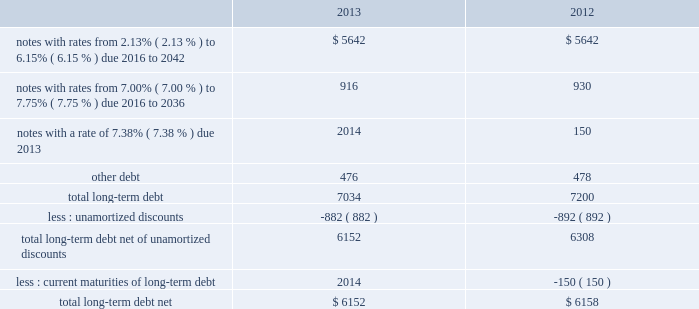As of december 31 , 2013 and 2012 , our liabilities associated with unrecognized tax benefits are not material .
We and our subsidiaries file income tax returns in the u.s .
Federal jurisdiction and various foreign jurisdictions .
With few exceptions , the statute of limitations is no longer open for u.s .
Federal or non-u.s .
Income tax examinations for the years before 2010 , other than with respect to refunds .
U.s .
Income taxes and foreign withholding taxes have not been provided on earnings of $ 222 million , $ 211 million , and $ 193 million that have not been distributed by our non-u.s .
Companies as of december 31 , 2013 , 2012 , and 2011 .
Our intention is to permanently reinvest these earnings , thereby indefinitely postponing their remittance to the u.s .
If these earnings were remitted , we estimate that the additional income taxes after foreign tax credits would have been approximately $ 50 million in 2013 , $ 45 million in 2012 , and $ 41 million in 2011 .
Our federal and foreign income tax payments , net of refunds received , were $ 787 million in 2013 , $ 890 million in 2012 , and $ 722 million in 2011 .
Our 2013 net payments reflect a $ 550 million refund from the irs primarily attributable to our tax-deductible discretionary pension contributions during the fourth quarter of 2012 ; our 2012 net payments reflect a $ 153 million refund from the irs related to a 2011 capital loss carryback claim ; and our 2011 net payments reflect a $ 250 million refund from the irs related to estimated taxes paid for 2010 .
As of december 31 , 2013 and 2012 , we had federal and foreign taxes receivable of $ 313 million and $ 662 million recorded within other current assets on our balance sheet , primarily attributable to our tax-deductible discretionary pension contributions in the fourth quarter of 2013 and 2012 and our debt exchange transaction in the fourth quarter of 2012 .
Note 9 2013 debt our long-term debt consisted of the following ( in millions ) : .
In december 2012 , we issued notes totaling $ 1.3 billion with a fixed interest rate of 4.07% ( 4.07 % ) maturing in december 2042 ( the new notes ) in exchange for outstanding notes totaling $ 1.2 billion with interest rates ranging from 5.50% ( 5.50 % ) to 8.50% ( 8.50 % ) maturing in 2023 to 2040 ( the old notes ) .
In connection with the exchange , we paid a premium of $ 393 million , of which $ 225 million was paid in cash and $ 168 million was in the form of new notes .
This premium , in addition to $ 194 million in remaining unamortized discounts related to the old notes , will be amortized as additional interest expense over the term of the new notes using the effective interest method .
We may , at our option , redeem some or all of the new notes at any time by paying the principal amount of notes being redeemed plus a make-whole premium and accrued and unpaid interest .
Interest on the new notes is payable on june 15 and december 15 of each year , beginning on june 15 , 2013 .
The new notes are unsecured senior obligations and rank equally in right of payment with all of our existing and future unsecured and unsubordinated indebtedness .
In september 2011 , we issued $ 2.0 billion of long-term notes in a registered public offering and in october 2011 , we used a portion of the proceeds to redeem all of our $ 500 million long-term notes maturing in 2013 .
In 2011 , we repurchased $ 84 million of our long-term notes through open-market purchases .
We paid premiums of $ 48 million in connection with the early extinguishments of debt , which were recognized in other non-operating income ( expense ) , net .
At december 31 , 2013 and 2012 , we had in place with a group of banks a $ 1.5 billion revolving credit facility that expires in august 2016 .
We may request and the banks may grant , at their discretion , an increase to the credit facility by an additional amount up to $ 500 million .
There were no borrowings outstanding under the credit facility through december 31 , 2013 .
Borrowings under the credit facility would be unsecured and bear interest at rates based , at our option , on a eurodollar rate or a base rate , as defined in the credit facility .
Each bank 2019s obligation to make loans under the credit facility is subject .
What was the percent of the change in the total long-term debt net of unamortized discounts from 2012 to 2013? 
Computations: ((6152 / 6308) / 6308)
Answer: 0.00015. As of december 31 , 2013 and 2012 , our liabilities associated with unrecognized tax benefits are not material .
We and our subsidiaries file income tax returns in the u.s .
Federal jurisdiction and various foreign jurisdictions .
With few exceptions , the statute of limitations is no longer open for u.s .
Federal or non-u.s .
Income tax examinations for the years before 2010 , other than with respect to refunds .
U.s .
Income taxes and foreign withholding taxes have not been provided on earnings of $ 222 million , $ 211 million , and $ 193 million that have not been distributed by our non-u.s .
Companies as of december 31 , 2013 , 2012 , and 2011 .
Our intention is to permanently reinvest these earnings , thereby indefinitely postponing their remittance to the u.s .
If these earnings were remitted , we estimate that the additional income taxes after foreign tax credits would have been approximately $ 50 million in 2013 , $ 45 million in 2012 , and $ 41 million in 2011 .
Our federal and foreign income tax payments , net of refunds received , were $ 787 million in 2013 , $ 890 million in 2012 , and $ 722 million in 2011 .
Our 2013 net payments reflect a $ 550 million refund from the irs primarily attributable to our tax-deductible discretionary pension contributions during the fourth quarter of 2012 ; our 2012 net payments reflect a $ 153 million refund from the irs related to a 2011 capital loss carryback claim ; and our 2011 net payments reflect a $ 250 million refund from the irs related to estimated taxes paid for 2010 .
As of december 31 , 2013 and 2012 , we had federal and foreign taxes receivable of $ 313 million and $ 662 million recorded within other current assets on our balance sheet , primarily attributable to our tax-deductible discretionary pension contributions in the fourth quarter of 2013 and 2012 and our debt exchange transaction in the fourth quarter of 2012 .
Note 9 2013 debt our long-term debt consisted of the following ( in millions ) : .
In december 2012 , we issued notes totaling $ 1.3 billion with a fixed interest rate of 4.07% ( 4.07 % ) maturing in december 2042 ( the new notes ) in exchange for outstanding notes totaling $ 1.2 billion with interest rates ranging from 5.50% ( 5.50 % ) to 8.50% ( 8.50 % ) maturing in 2023 to 2040 ( the old notes ) .
In connection with the exchange , we paid a premium of $ 393 million , of which $ 225 million was paid in cash and $ 168 million was in the form of new notes .
This premium , in addition to $ 194 million in remaining unamortized discounts related to the old notes , will be amortized as additional interest expense over the term of the new notes using the effective interest method .
We may , at our option , redeem some or all of the new notes at any time by paying the principal amount of notes being redeemed plus a make-whole premium and accrued and unpaid interest .
Interest on the new notes is payable on june 15 and december 15 of each year , beginning on june 15 , 2013 .
The new notes are unsecured senior obligations and rank equally in right of payment with all of our existing and future unsecured and unsubordinated indebtedness .
In september 2011 , we issued $ 2.0 billion of long-term notes in a registered public offering and in october 2011 , we used a portion of the proceeds to redeem all of our $ 500 million long-term notes maturing in 2013 .
In 2011 , we repurchased $ 84 million of our long-term notes through open-market purchases .
We paid premiums of $ 48 million in connection with the early extinguishments of debt , which were recognized in other non-operating income ( expense ) , net .
At december 31 , 2013 and 2012 , we had in place with a group of banks a $ 1.5 billion revolving credit facility that expires in august 2016 .
We may request and the banks may grant , at their discretion , an increase to the credit facility by an additional amount up to $ 500 million .
There were no borrowings outstanding under the credit facility through december 31 , 2013 .
Borrowings under the credit facility would be unsecured and bear interest at rates based , at our option , on a eurodollar rate or a base rate , as defined in the credit facility .
Each bank 2019s obligation to make loans under the credit facility is subject .
What was the change in millions of total long-term debt net between 2012 and 2013? 
Computations: (6152 - 6158)
Answer: -6.0. 